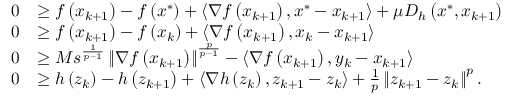Convert formula to latex. <formula><loc_0><loc_0><loc_500><loc_500>\begin{array} { r l } { 0 } & { \geq f \left ( x _ { k + 1 } \right ) - f \left ( x ^ { * } \right ) + \left \langle \nabla f \left ( x _ { k + 1 } \right ) , x ^ { * } - x _ { k + 1 } \right \rangle + \mu D _ { h } \left ( x ^ { * } , x _ { k + 1 } \right ) } \\ { 0 } & { \geq f \left ( x _ { k + 1 } \right ) - f \left ( x _ { k } \right ) + \left \langle \nabla f \left ( x _ { k + 1 } \right ) , x _ { k } - x _ { k + 1 } \right \rangle } \\ { 0 } & { \geq M s ^ { \frac { 1 } { p - 1 } } \left \| \nabla f \left ( x _ { k + 1 } \right ) \right \| ^ { \frac { p } { p - 1 } } - \left \langle \nabla f \left ( x _ { k + 1 } \right ) , y _ { k } - x _ { k + 1 } \right \rangle } \\ { 0 } & { \geq h \left ( z _ { k } \right ) - h \left ( z _ { k + 1 } \right ) + \left \langle \nabla h \left ( z _ { k } \right ) , z _ { k + 1 } - z _ { k } \right \rangle + \frac { 1 } { p } \left \| z _ { k + 1 } - z _ { k } \right \| ^ { p } . } \end{array}</formula> 